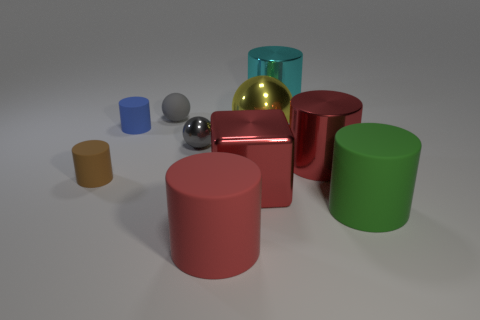What size is the rubber thing that is behind the tiny blue cylinder?
Offer a very short reply. Small. Are the yellow thing and the large green cylinder made of the same material?
Provide a short and direct response. No. What shape is the tiny object that is the same material as the red cube?
Provide a short and direct response. Sphere. Is there anything else that is the same color as the cube?
Offer a very short reply. Yes. There is a large rubber object on the left side of the large cyan metallic thing; what is its color?
Your response must be concise. Red. Does the small rubber cylinder behind the tiny brown thing have the same color as the big sphere?
Your answer should be very brief. No. There is a cyan thing that is the same shape as the brown thing; what material is it?
Your response must be concise. Metal. How many cyan metal cylinders are the same size as the metallic block?
Provide a succinct answer. 1. The tiny shiny thing has what shape?
Provide a short and direct response. Sphere. How big is the cylinder that is both to the right of the large red metallic cube and in front of the metallic block?
Give a very brief answer. Large. 